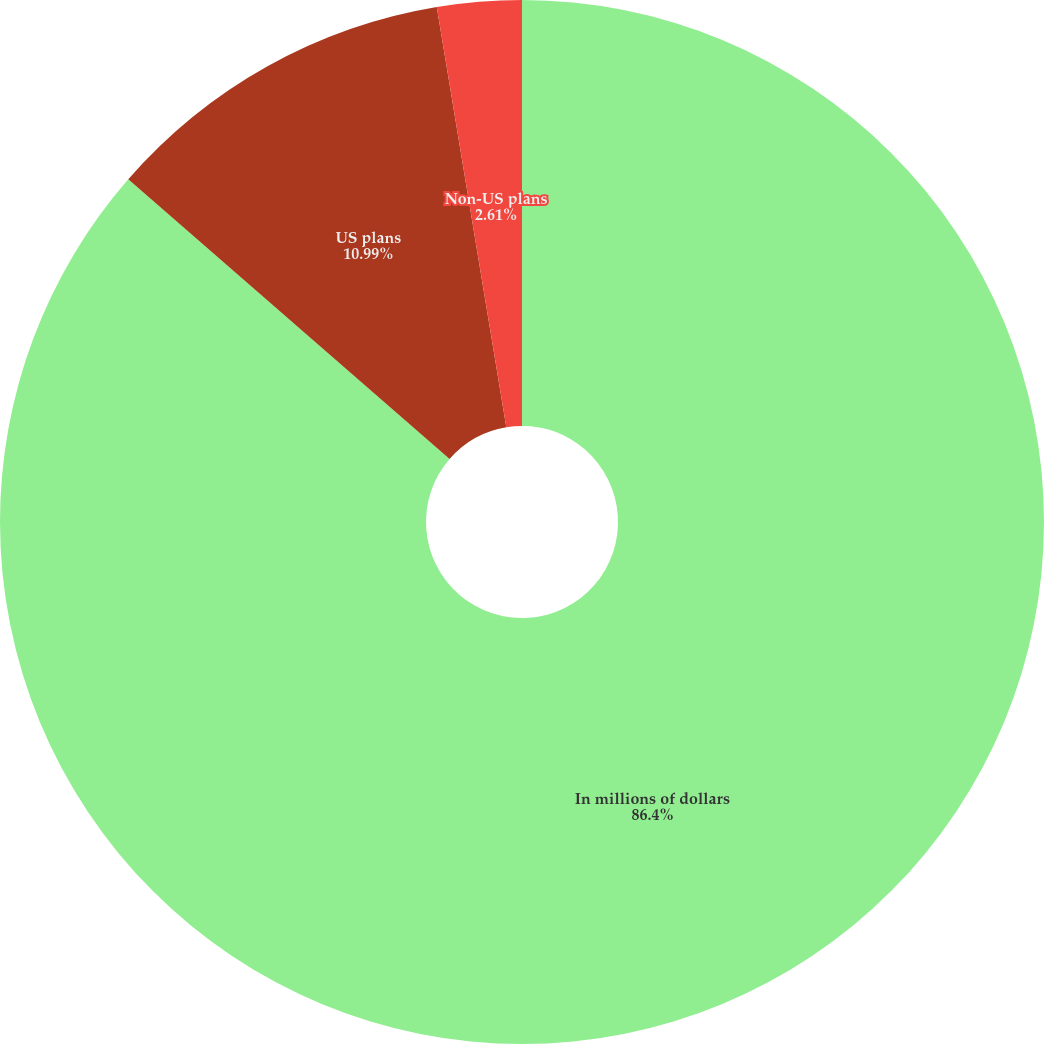Convert chart to OTSL. <chart><loc_0><loc_0><loc_500><loc_500><pie_chart><fcel>In millions of dollars<fcel>US plans<fcel>Non-US plans<nl><fcel>86.39%<fcel>10.99%<fcel>2.61%<nl></chart> 